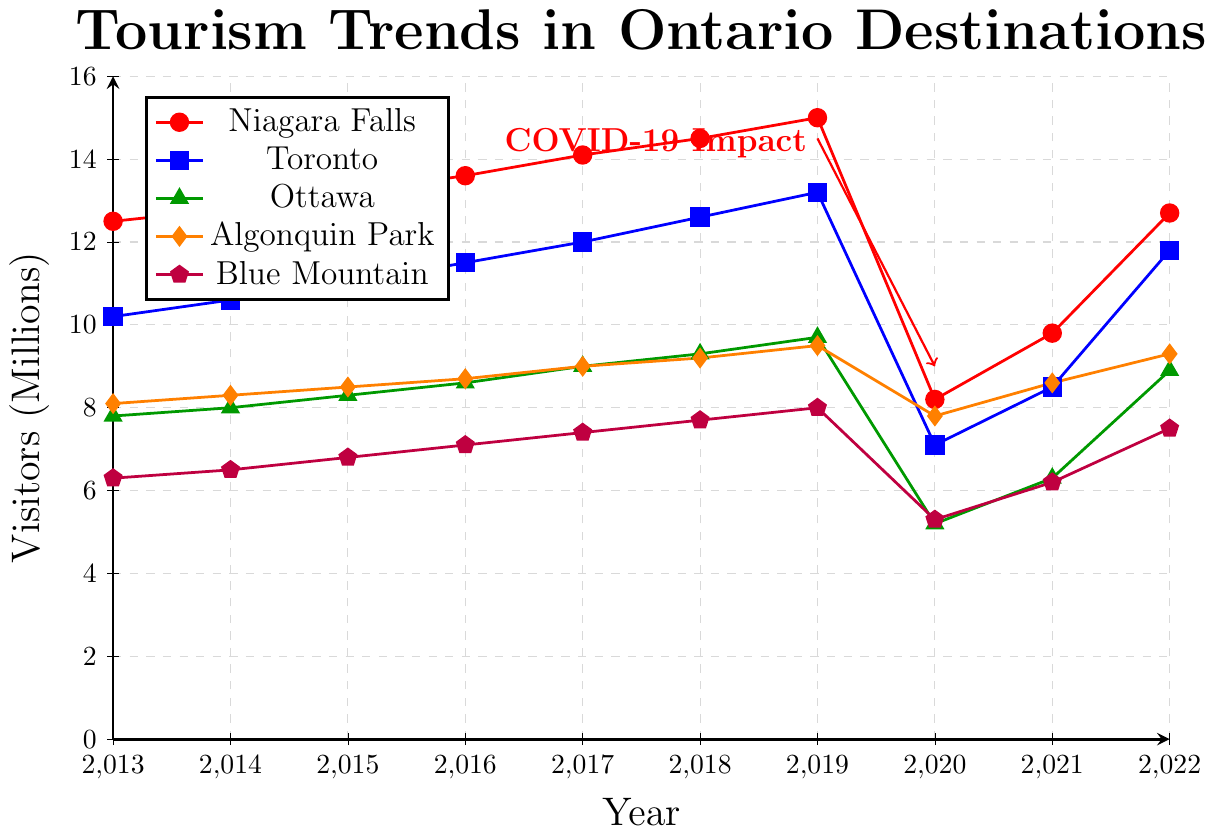What was the visitor count for Niagara Falls in 2020, and how did it compare to 2019? To find the difference, look at the visitor count in both years. For 2019, Niagara Falls had 15 million visitors, and in 2020, it had 8.2 million. The difference is 15 - 8.2. This means the visitor count decreased by 6.8 million.
Answer: 6.8 million decrease Which location saw the least impact from COVID-19 in terms of visitor decline between 2019 and 2020? Check the visitor counts in 2019 and 2020 for all locations. The differences are: Niagara Falls (15 - 8.2), Toronto (13.2 - 7.1), Ottawa (9.7 - 5.2), Algonquin Park (9.5 - 7.8), Blue Mountain (8.0 - 5.3). This translates to declines of 6.8, 6.1, 4.5, 1.7, and 2.7 million visitors respectively. Algonquin Park saw the smallest decline.
Answer: Algonquin Park What was the total number of visitors to Toronto over the last decade? Add up the visitor counts for Toronto from 2013 to 2022. The values are 10.2, 10.6, 11.0, 11.5, 12.0, 12.6, 13.2, 7.1, 8.5, and 11.8. Summing them yields 108.5 million visitors.
Answer: 108.5 million Which destination had the highest visitor count in 2022, and what was it? Look at the visitor counts for 2022. Niagara Falls had 12.7 million, Toronto had 11.8 million, Ottawa had 8.9 million, Algonquin Park had 9.3 million, and Blue Mountain had 7.5 million. Niagara Falls had the highest count.
Answer: Niagara Falls, 12.7 million By what percentage did visitors to Blue Mountain decrease from 2019 to 2020? Find the difference first: 8.0 (2019) - 5.3 (2020) = 2.7 million. Next, to find the percentage decrease, divide the difference by the 2019 visitors: 2.7/8.0 = 0.3375. Convert to a percentage: 0.3375 * 100 = 33.75%.
Answer: 33.75% What trend can be seen in the visitor count for Algonquin Park over the decade? Examine the values from 2013 to 2022. The visitor count gradually increases from 8.1 million in 2013 to 9.5 million in 2019, drops to 7.8 million in 2020, then largely recovers by 2022 with 9.3 million. The general trend is an increase with a dip in 2020, likely due to COVID-19.
Answer: General increase with a 2020 dip What was the average annual visitor count for Ottawa from 2013 to 2022? Add the visitor counts and divide by the number of years. The counts are 7.8, 8.0, 8.3, 8.6, 9.0, 9.3, 9.7, 5.2, 6.3, and 8.9. Their sum is 80.1; divided by 10, the average is 8.01 million.
Answer: 8.01 million Which year saw the lowest visitor counts across all destinations? Review the data for each destination year-by-year. All destinations saw a significant drop in 2020, making it the year with the lowest visitor counts: Niagara Falls (8.2), Toronto (7.1), Ottawa (5.2), Algonquin Park (7.8), Blue Mountain (5.3).
Answer: 2020 